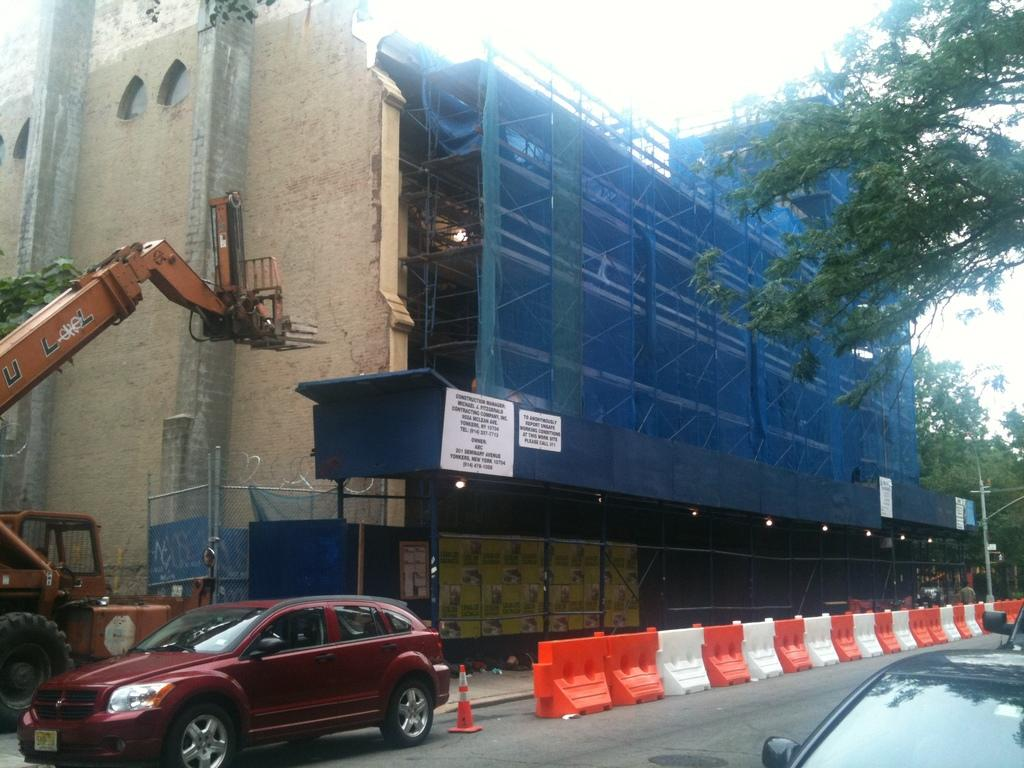What type of structure is visible in the image? There is a building in the image. What are some features of the building? The building has walls, pillars, and rods. What can be seen at the bottom of the image? There are vehicles, a traffic cone, a pole, and a road at the bottom of the image. What type of vegetation is on the right side of the image? There are trees on the right side of the image. How does the building take a bath in the image? The building does not take a bath in the image; it is a stationary structure. What type of breath can be seen coming from the trees in the image? There is no breath visible in the image, as trees do not breathe like humans or animals. 